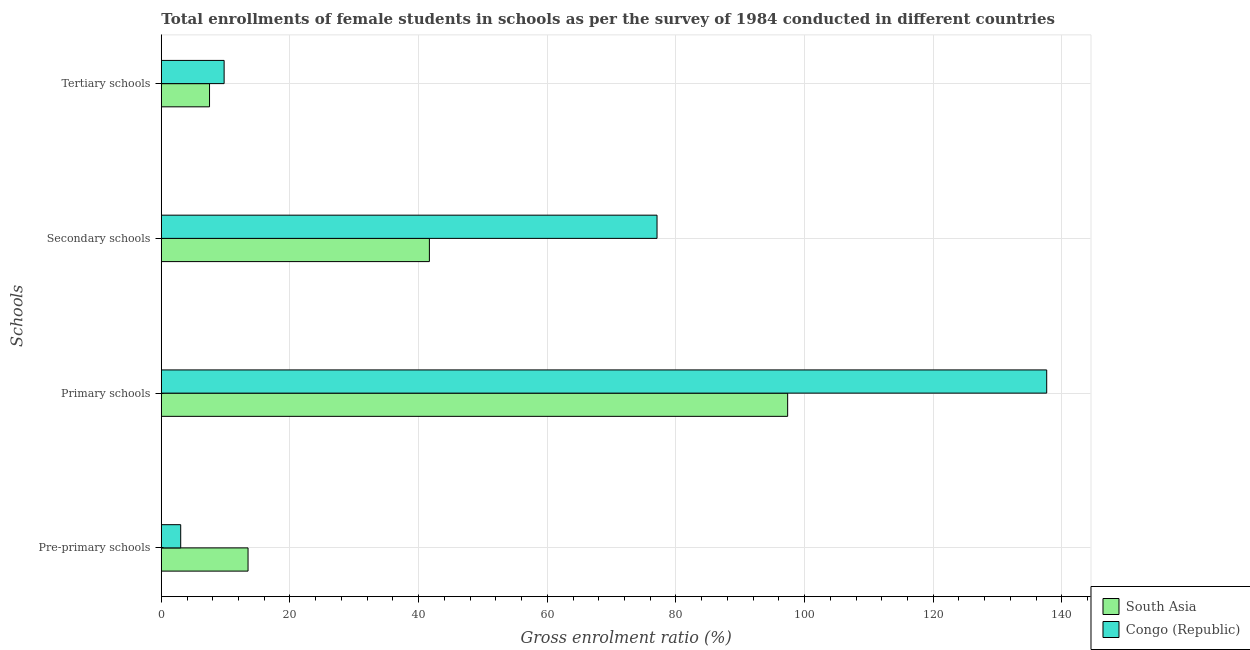How many different coloured bars are there?
Your response must be concise. 2. Are the number of bars per tick equal to the number of legend labels?
Keep it short and to the point. Yes. How many bars are there on the 4th tick from the bottom?
Provide a short and direct response. 2. What is the label of the 4th group of bars from the top?
Ensure brevity in your answer.  Pre-primary schools. What is the gross enrolment ratio(female) in primary schools in South Asia?
Your response must be concise. 97.37. Across all countries, what is the maximum gross enrolment ratio(female) in tertiary schools?
Offer a terse response. 9.76. Across all countries, what is the minimum gross enrolment ratio(female) in primary schools?
Offer a terse response. 97.37. In which country was the gross enrolment ratio(female) in tertiary schools maximum?
Provide a short and direct response. Congo (Republic). In which country was the gross enrolment ratio(female) in secondary schools minimum?
Offer a terse response. South Asia. What is the total gross enrolment ratio(female) in secondary schools in the graph?
Ensure brevity in your answer.  118.74. What is the difference between the gross enrolment ratio(female) in primary schools in Congo (Republic) and that in South Asia?
Your answer should be very brief. 40.27. What is the difference between the gross enrolment ratio(female) in tertiary schools in Congo (Republic) and the gross enrolment ratio(female) in secondary schools in South Asia?
Your response must be concise. -31.91. What is the average gross enrolment ratio(female) in pre-primary schools per country?
Offer a very short reply. 8.25. What is the difference between the gross enrolment ratio(female) in primary schools and gross enrolment ratio(female) in pre-primary schools in Congo (Republic)?
Offer a terse response. 134.63. What is the ratio of the gross enrolment ratio(female) in secondary schools in South Asia to that in Congo (Republic)?
Offer a very short reply. 0.54. What is the difference between the highest and the second highest gross enrolment ratio(female) in secondary schools?
Your answer should be very brief. 35.39. What is the difference between the highest and the lowest gross enrolment ratio(female) in tertiary schools?
Offer a very short reply. 2.27. Is it the case that in every country, the sum of the gross enrolment ratio(female) in primary schools and gross enrolment ratio(female) in pre-primary schools is greater than the sum of gross enrolment ratio(female) in tertiary schools and gross enrolment ratio(female) in secondary schools?
Make the answer very short. No. What does the 1st bar from the top in Secondary schools represents?
Give a very brief answer. Congo (Republic). What does the 2nd bar from the bottom in Pre-primary schools represents?
Your response must be concise. Congo (Republic). How many bars are there?
Ensure brevity in your answer.  8. What is the difference between two consecutive major ticks on the X-axis?
Your answer should be compact. 20. Are the values on the major ticks of X-axis written in scientific E-notation?
Provide a short and direct response. No. Where does the legend appear in the graph?
Provide a short and direct response. Bottom right. How are the legend labels stacked?
Provide a short and direct response. Vertical. What is the title of the graph?
Make the answer very short. Total enrollments of female students in schools as per the survey of 1984 conducted in different countries. What is the label or title of the Y-axis?
Provide a short and direct response. Schools. What is the Gross enrolment ratio (%) in South Asia in Pre-primary schools?
Provide a succinct answer. 13.48. What is the Gross enrolment ratio (%) of Congo (Republic) in Pre-primary schools?
Make the answer very short. 3.01. What is the Gross enrolment ratio (%) of South Asia in Primary schools?
Provide a short and direct response. 97.37. What is the Gross enrolment ratio (%) in Congo (Republic) in Primary schools?
Offer a terse response. 137.64. What is the Gross enrolment ratio (%) of South Asia in Secondary schools?
Your answer should be compact. 41.68. What is the Gross enrolment ratio (%) in Congo (Republic) in Secondary schools?
Provide a short and direct response. 77.06. What is the Gross enrolment ratio (%) in South Asia in Tertiary schools?
Provide a short and direct response. 7.5. What is the Gross enrolment ratio (%) of Congo (Republic) in Tertiary schools?
Your answer should be very brief. 9.76. Across all Schools, what is the maximum Gross enrolment ratio (%) of South Asia?
Make the answer very short. 97.37. Across all Schools, what is the maximum Gross enrolment ratio (%) of Congo (Republic)?
Your answer should be compact. 137.64. Across all Schools, what is the minimum Gross enrolment ratio (%) in South Asia?
Keep it short and to the point. 7.5. Across all Schools, what is the minimum Gross enrolment ratio (%) in Congo (Republic)?
Your answer should be very brief. 3.01. What is the total Gross enrolment ratio (%) of South Asia in the graph?
Ensure brevity in your answer.  160.03. What is the total Gross enrolment ratio (%) in Congo (Republic) in the graph?
Provide a succinct answer. 227.48. What is the difference between the Gross enrolment ratio (%) of South Asia in Pre-primary schools and that in Primary schools?
Your answer should be very brief. -83.89. What is the difference between the Gross enrolment ratio (%) in Congo (Republic) in Pre-primary schools and that in Primary schools?
Offer a very short reply. -134.63. What is the difference between the Gross enrolment ratio (%) of South Asia in Pre-primary schools and that in Secondary schools?
Provide a short and direct response. -28.19. What is the difference between the Gross enrolment ratio (%) of Congo (Republic) in Pre-primary schools and that in Secondary schools?
Your answer should be very brief. -74.05. What is the difference between the Gross enrolment ratio (%) in South Asia in Pre-primary schools and that in Tertiary schools?
Your response must be concise. 5.99. What is the difference between the Gross enrolment ratio (%) of Congo (Republic) in Pre-primary schools and that in Tertiary schools?
Keep it short and to the point. -6.75. What is the difference between the Gross enrolment ratio (%) in South Asia in Primary schools and that in Secondary schools?
Your response must be concise. 55.7. What is the difference between the Gross enrolment ratio (%) in Congo (Republic) in Primary schools and that in Secondary schools?
Your answer should be compact. 60.58. What is the difference between the Gross enrolment ratio (%) of South Asia in Primary schools and that in Tertiary schools?
Give a very brief answer. 89.88. What is the difference between the Gross enrolment ratio (%) in Congo (Republic) in Primary schools and that in Tertiary schools?
Keep it short and to the point. 127.88. What is the difference between the Gross enrolment ratio (%) in South Asia in Secondary schools and that in Tertiary schools?
Your answer should be very brief. 34.18. What is the difference between the Gross enrolment ratio (%) in Congo (Republic) in Secondary schools and that in Tertiary schools?
Your answer should be very brief. 67.3. What is the difference between the Gross enrolment ratio (%) of South Asia in Pre-primary schools and the Gross enrolment ratio (%) of Congo (Republic) in Primary schools?
Offer a terse response. -124.16. What is the difference between the Gross enrolment ratio (%) in South Asia in Pre-primary schools and the Gross enrolment ratio (%) in Congo (Republic) in Secondary schools?
Provide a succinct answer. -63.58. What is the difference between the Gross enrolment ratio (%) in South Asia in Pre-primary schools and the Gross enrolment ratio (%) in Congo (Republic) in Tertiary schools?
Offer a terse response. 3.72. What is the difference between the Gross enrolment ratio (%) of South Asia in Primary schools and the Gross enrolment ratio (%) of Congo (Republic) in Secondary schools?
Keep it short and to the point. 20.31. What is the difference between the Gross enrolment ratio (%) of South Asia in Primary schools and the Gross enrolment ratio (%) of Congo (Republic) in Tertiary schools?
Make the answer very short. 87.61. What is the difference between the Gross enrolment ratio (%) in South Asia in Secondary schools and the Gross enrolment ratio (%) in Congo (Republic) in Tertiary schools?
Offer a terse response. 31.91. What is the average Gross enrolment ratio (%) of South Asia per Schools?
Offer a very short reply. 40.01. What is the average Gross enrolment ratio (%) of Congo (Republic) per Schools?
Offer a terse response. 56.87. What is the difference between the Gross enrolment ratio (%) of South Asia and Gross enrolment ratio (%) of Congo (Republic) in Pre-primary schools?
Keep it short and to the point. 10.47. What is the difference between the Gross enrolment ratio (%) in South Asia and Gross enrolment ratio (%) in Congo (Republic) in Primary schools?
Your answer should be compact. -40.27. What is the difference between the Gross enrolment ratio (%) of South Asia and Gross enrolment ratio (%) of Congo (Republic) in Secondary schools?
Offer a very short reply. -35.39. What is the difference between the Gross enrolment ratio (%) of South Asia and Gross enrolment ratio (%) of Congo (Republic) in Tertiary schools?
Your answer should be very brief. -2.27. What is the ratio of the Gross enrolment ratio (%) of South Asia in Pre-primary schools to that in Primary schools?
Your answer should be very brief. 0.14. What is the ratio of the Gross enrolment ratio (%) of Congo (Republic) in Pre-primary schools to that in Primary schools?
Offer a terse response. 0.02. What is the ratio of the Gross enrolment ratio (%) in South Asia in Pre-primary schools to that in Secondary schools?
Your answer should be very brief. 0.32. What is the ratio of the Gross enrolment ratio (%) of Congo (Republic) in Pre-primary schools to that in Secondary schools?
Provide a succinct answer. 0.04. What is the ratio of the Gross enrolment ratio (%) of South Asia in Pre-primary schools to that in Tertiary schools?
Ensure brevity in your answer.  1.8. What is the ratio of the Gross enrolment ratio (%) of Congo (Republic) in Pre-primary schools to that in Tertiary schools?
Provide a short and direct response. 0.31. What is the ratio of the Gross enrolment ratio (%) of South Asia in Primary schools to that in Secondary schools?
Provide a short and direct response. 2.34. What is the ratio of the Gross enrolment ratio (%) of Congo (Republic) in Primary schools to that in Secondary schools?
Ensure brevity in your answer.  1.79. What is the ratio of the Gross enrolment ratio (%) of South Asia in Primary schools to that in Tertiary schools?
Give a very brief answer. 12.99. What is the ratio of the Gross enrolment ratio (%) of Congo (Republic) in Primary schools to that in Tertiary schools?
Give a very brief answer. 14.1. What is the ratio of the Gross enrolment ratio (%) in South Asia in Secondary schools to that in Tertiary schools?
Your answer should be compact. 5.56. What is the ratio of the Gross enrolment ratio (%) of Congo (Republic) in Secondary schools to that in Tertiary schools?
Your answer should be compact. 7.89. What is the difference between the highest and the second highest Gross enrolment ratio (%) of South Asia?
Make the answer very short. 55.7. What is the difference between the highest and the second highest Gross enrolment ratio (%) of Congo (Republic)?
Give a very brief answer. 60.58. What is the difference between the highest and the lowest Gross enrolment ratio (%) of South Asia?
Your answer should be very brief. 89.88. What is the difference between the highest and the lowest Gross enrolment ratio (%) in Congo (Republic)?
Ensure brevity in your answer.  134.63. 